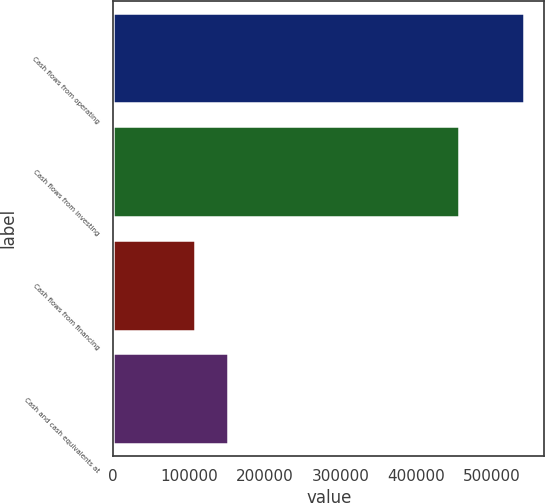Convert chart. <chart><loc_0><loc_0><loc_500><loc_500><bar_chart><fcel>Cash flows from operating<fcel>Cash flows from investing<fcel>Cash flows from financing<fcel>Cash and cash equivalents at<nl><fcel>541760<fcel>456646<fcel>108511<fcel>151836<nl></chart> 